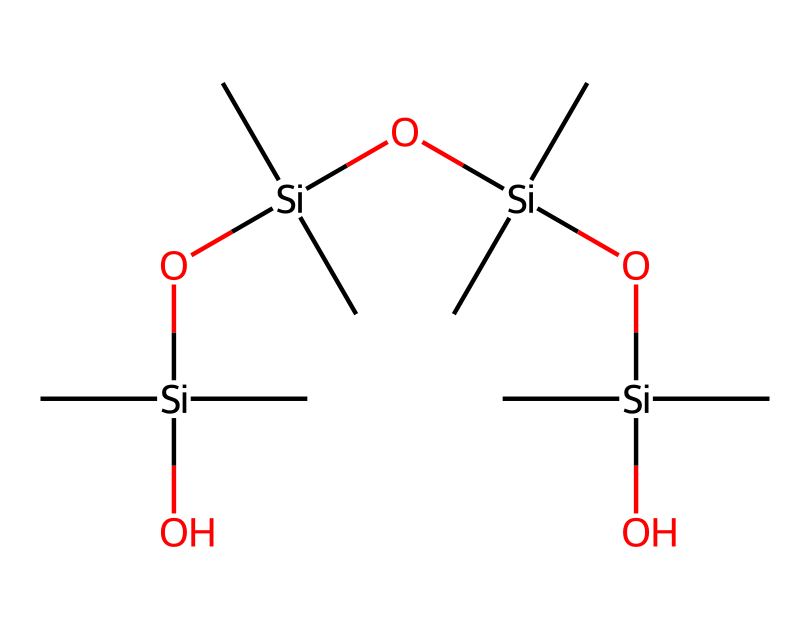how many silicon atoms are present in this chemical structure? The SMILES indicates that there are several 'Si' representations in the chain. By counting each 'Si', we determine that there are four silicon atoms in total.
Answer: four what is the primary component of silly putty based on the SMILES structure? The structure indicates multiple silicon and oxygen connections, typical of silicones which is the main component of silly putty.
Answer: silicones how many oxygen atoms are found in this chemical? By observing the SMILES, we can identify 'O' representations. This structure shows three oxygen atoms connected across the silicate units.
Answer: three What property of silly putty is suggested by its structure being a non-Newtonian fluid? The branched silicate structure allows the material to exhibit properties like viscosity change under stress, which is characteristic of non-Newtonian fluids.
Answer: viscosity change what type of bonding is mainly present in this chemical structure? The chemical structure predominantly contains silicon-oxygen (Si-O) bonds, representative of silicate polymers that provide elasticity and flexibility.
Answer: silicon-oxygen bonds how does the structure contribute to the non-Newtonian behavior of silly putty? The extended branching chains and cross-linked silicates in the structure create resistance when force is applied, revealing its non-Newtonian characteristics such as shear-thickening or viscosity changes.
Answer: resistance under force 